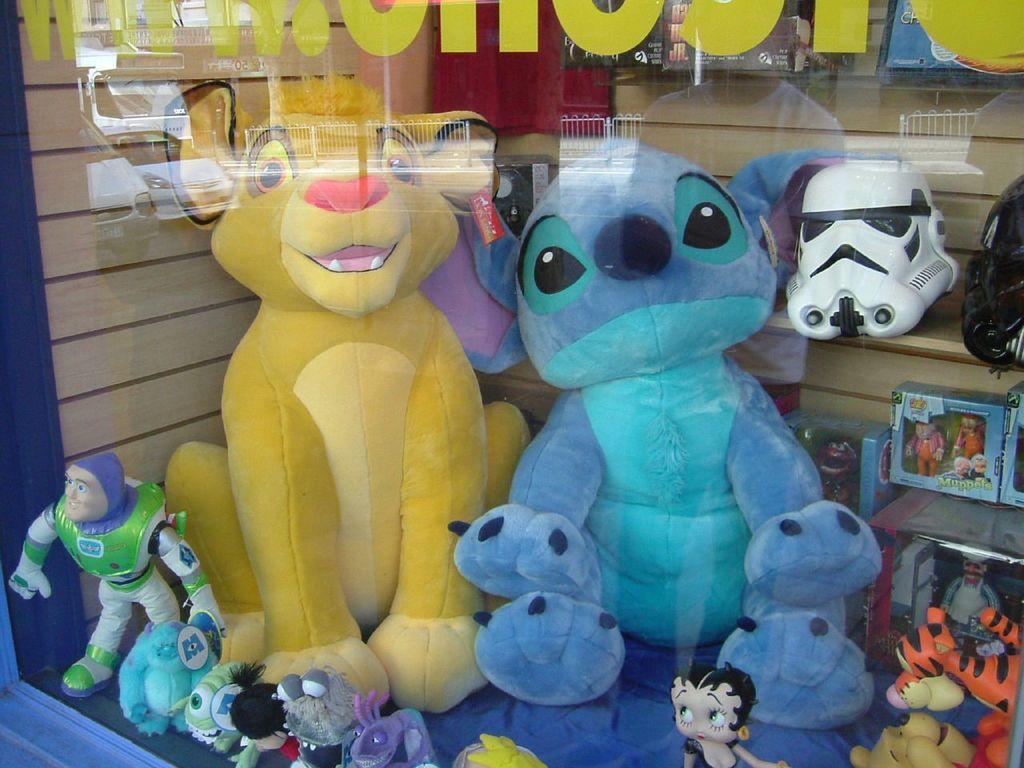In one or two sentences, can you explain what this image depicts? In this image I can see the toy store. I can see few colorful toys and few toys on the rack. In front I can see the glass. 